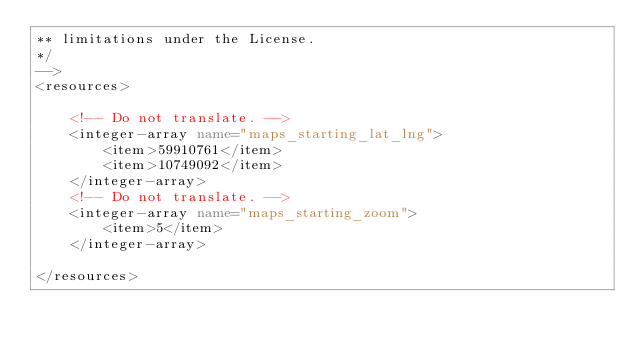<code> <loc_0><loc_0><loc_500><loc_500><_XML_>** limitations under the License.
*/
-->
<resources>

    <!-- Do not translate. -->
    <integer-array name="maps_starting_lat_lng">
        <item>59910761</item>
        <item>10749092</item>
    </integer-array>
    <!-- Do not translate. -->
    <integer-array name="maps_starting_zoom">
        <item>5</item>
    </integer-array>

</resources>
</code> 